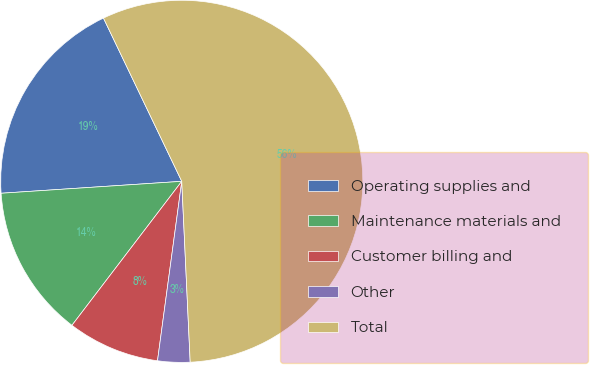Convert chart to OTSL. <chart><loc_0><loc_0><loc_500><loc_500><pie_chart><fcel>Operating supplies and<fcel>Maintenance materials and<fcel>Customer billing and<fcel>Other<fcel>Total<nl><fcel>18.93%<fcel>13.58%<fcel>8.23%<fcel>2.88%<fcel>56.37%<nl></chart> 